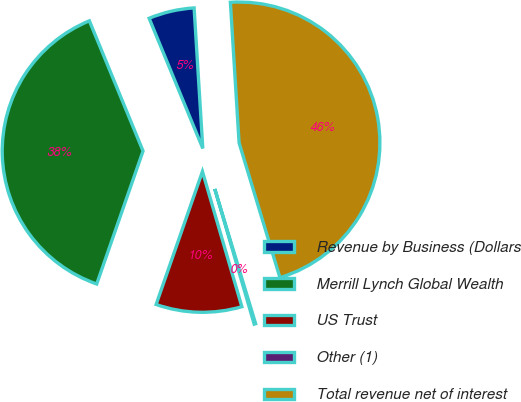Convert chart. <chart><loc_0><loc_0><loc_500><loc_500><pie_chart><fcel>Revenue by Business (Dollars<fcel>Merrill Lynch Global Wealth<fcel>US Trust<fcel>Other (1)<fcel>Total revenue net of interest<nl><fcel>5.24%<fcel>38.44%<fcel>9.85%<fcel>0.17%<fcel>46.3%<nl></chart> 